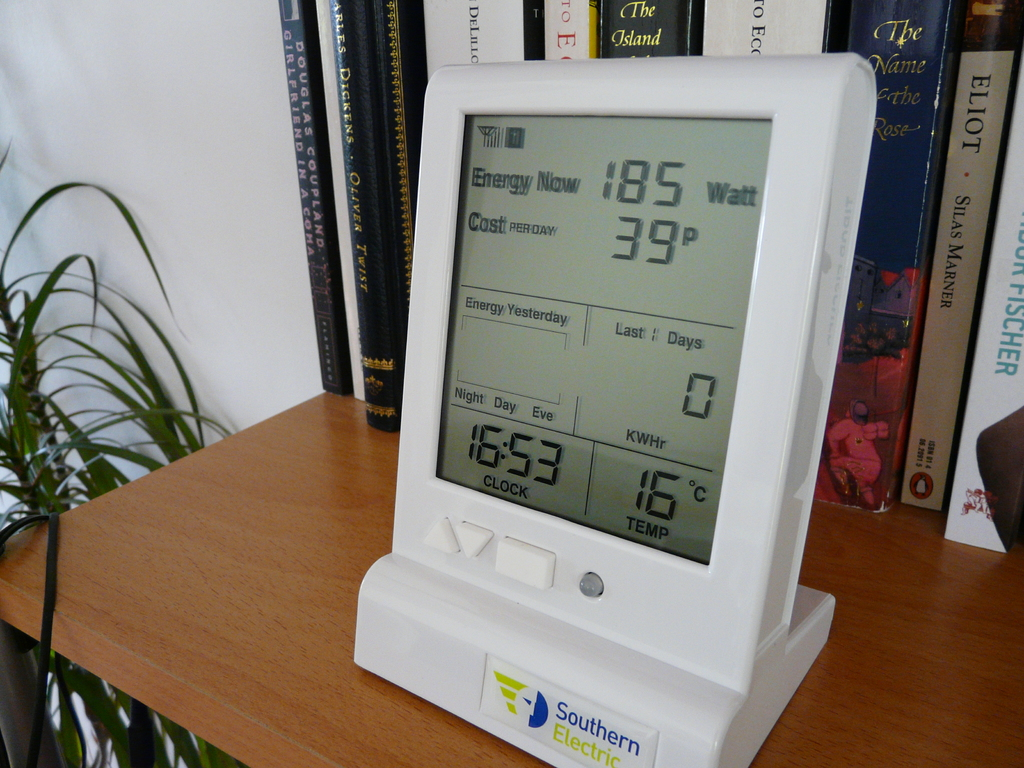How does this monitor contribute to environmental conservation? This energy monitor plays a pivotal role in promoting environmental conservation by providing real-time insights into an individual's or household's energy usage. Displaying instant data on energy consumption compels users to become more aware of their electrical usage habits, encouraging them to optimize their energy use, which can lead to reduced carbon footprints. This awareness can motivate a shift towards more energy-efficient appliances and behaviors, such as utilizing energy mostly during off-peak hours. By fostering energy conservation in daily life, such tools support broader efforts to mitigate environmental impacts and promote sustainability. 